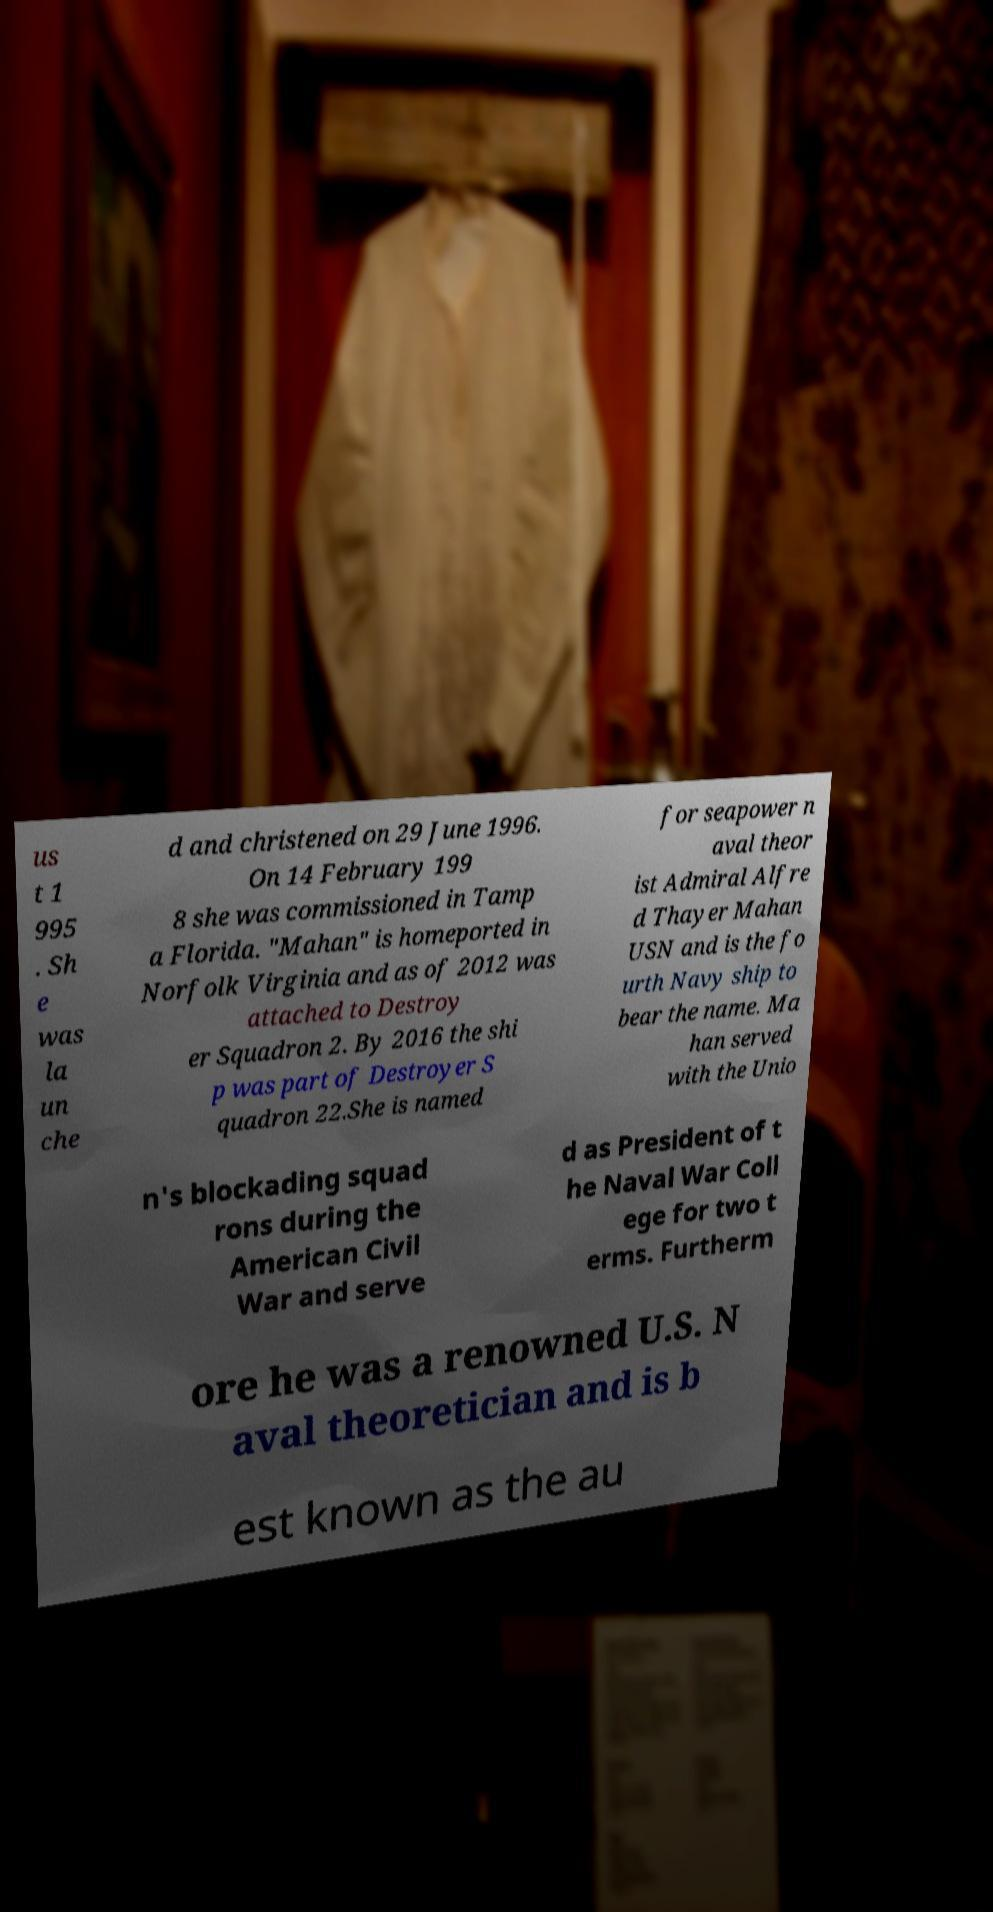Could you extract and type out the text from this image? us t 1 995 . Sh e was la un che d and christened on 29 June 1996. On 14 February 199 8 she was commissioned in Tamp a Florida. "Mahan" is homeported in Norfolk Virginia and as of 2012 was attached to Destroy er Squadron 2. By 2016 the shi p was part of Destroyer S quadron 22.She is named for seapower n aval theor ist Admiral Alfre d Thayer Mahan USN and is the fo urth Navy ship to bear the name. Ma han served with the Unio n's blockading squad rons during the American Civil War and serve d as President of t he Naval War Coll ege for two t erms. Furtherm ore he was a renowned U.S. N aval theoretician and is b est known as the au 